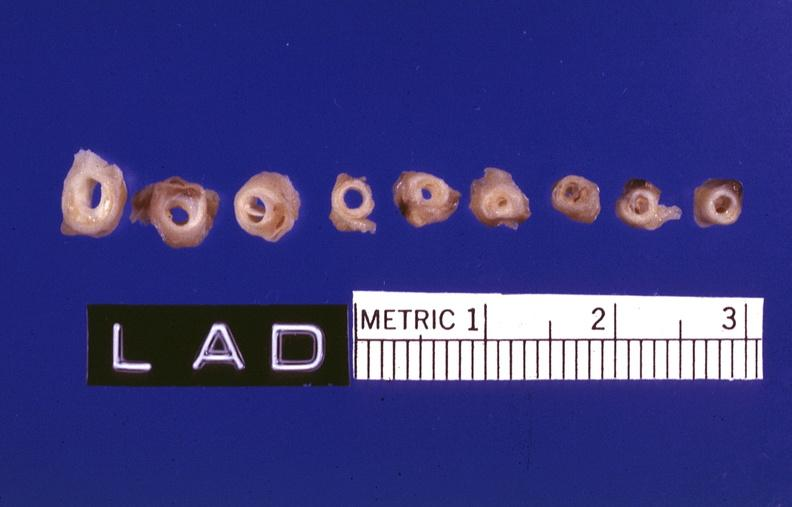s cardiovascular present?
Answer the question using a single word or phrase. Yes 